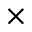<formula> <loc_0><loc_0><loc_500><loc_500>\times</formula> 